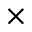<formula> <loc_0><loc_0><loc_500><loc_500>\times</formula> 